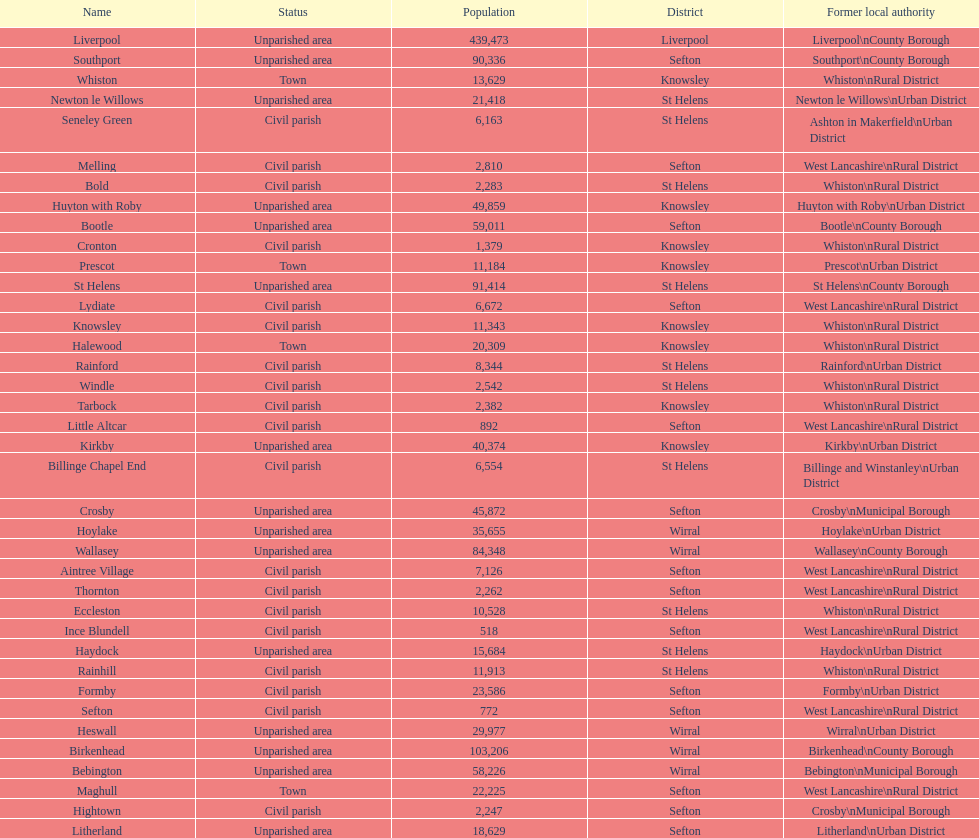How many people live in the bold civil parish? 2,283. 